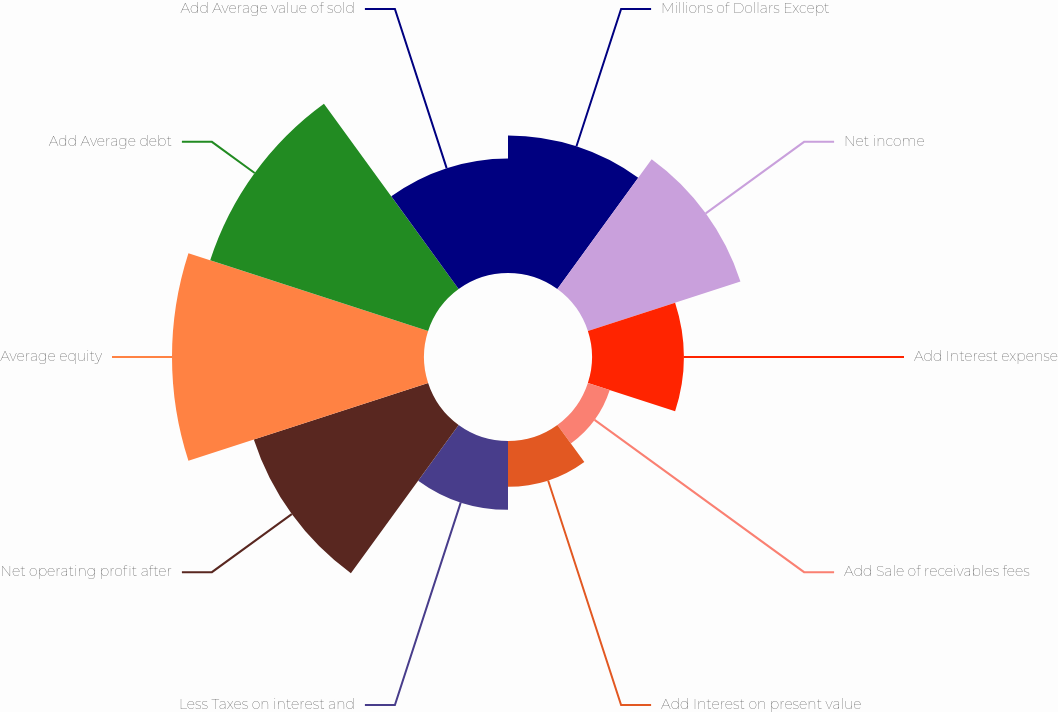Convert chart to OTSL. <chart><loc_0><loc_0><loc_500><loc_500><pie_chart><fcel>Millions of Dollars Except<fcel>Net income<fcel>Add Interest expense<fcel>Add Sale of receivables fees<fcel>Add Interest on present value<fcel>Less Taxes on interest and<fcel>Net operating profit after<fcel>Average equity<fcel>Add Average debt<fcel>Add Average value of sold<nl><fcel>10.53%<fcel>12.28%<fcel>7.02%<fcel>1.76%<fcel>3.51%<fcel>5.27%<fcel>14.03%<fcel>19.29%<fcel>17.54%<fcel>8.77%<nl></chart> 